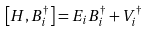Convert formula to latex. <formula><loc_0><loc_0><loc_500><loc_500>\left [ H , B ^ { \dagger } _ { i } \right ] = E _ { i } B ^ { \dagger } _ { i } + V ^ { \dagger } _ { i }</formula> 